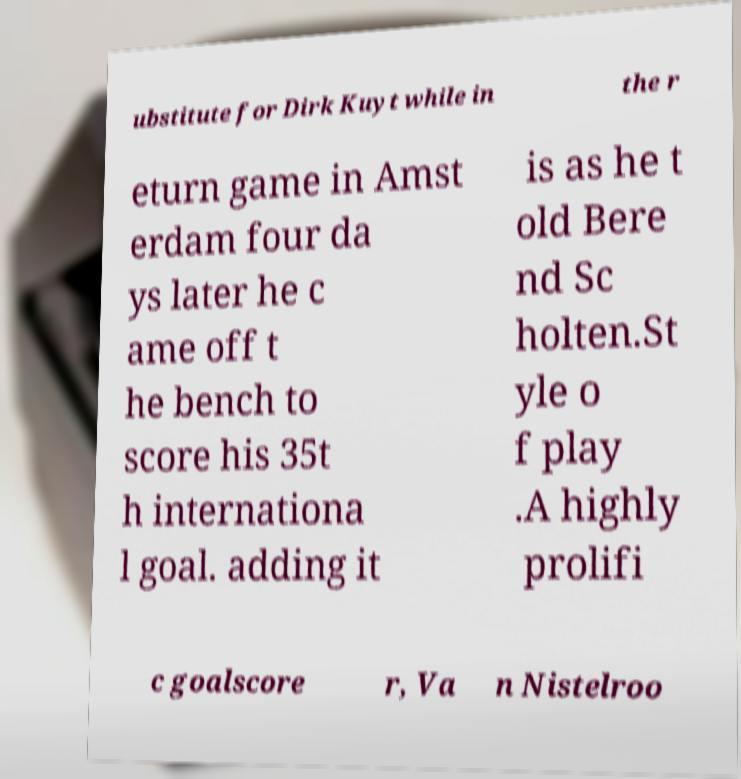I need the written content from this picture converted into text. Can you do that? ubstitute for Dirk Kuyt while in the r eturn game in Amst erdam four da ys later he c ame off t he bench to score his 35t h internationa l goal. adding it is as he t old Bere nd Sc holten.St yle o f play .A highly prolifi c goalscore r, Va n Nistelroo 